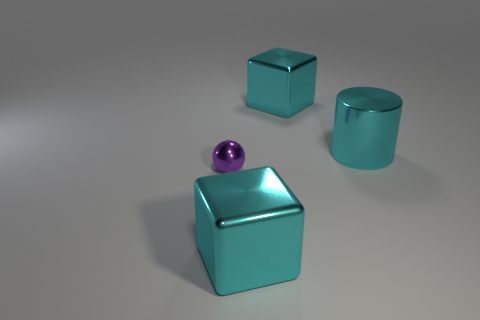Add 2 purple balls. How many objects exist? 6 Subtract all cylinders. How many objects are left? 3 Subtract 2 cyan blocks. How many objects are left? 2 Subtract all purple balls. Subtract all tiny brown matte balls. How many objects are left? 3 Add 2 tiny purple spheres. How many tiny purple spheres are left? 3 Add 2 tiny purple spheres. How many tiny purple spheres exist? 3 